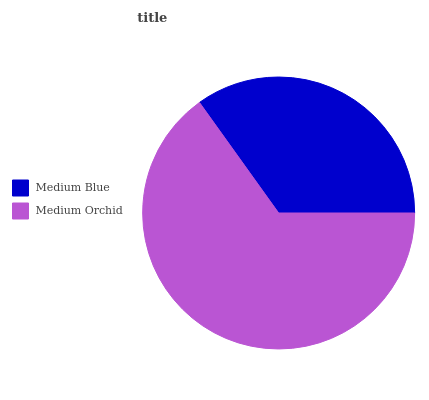Is Medium Blue the minimum?
Answer yes or no. Yes. Is Medium Orchid the maximum?
Answer yes or no. Yes. Is Medium Orchid the minimum?
Answer yes or no. No. Is Medium Orchid greater than Medium Blue?
Answer yes or no. Yes. Is Medium Blue less than Medium Orchid?
Answer yes or no. Yes. Is Medium Blue greater than Medium Orchid?
Answer yes or no. No. Is Medium Orchid less than Medium Blue?
Answer yes or no. No. Is Medium Orchid the high median?
Answer yes or no. Yes. Is Medium Blue the low median?
Answer yes or no. Yes. Is Medium Blue the high median?
Answer yes or no. No. Is Medium Orchid the low median?
Answer yes or no. No. 